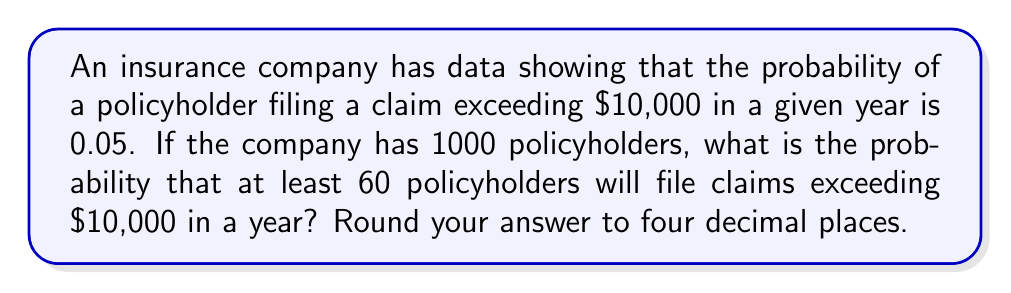Can you answer this question? To solve this problem, we'll use the binomial distribution and its normal approximation:

1) Let X be the number of policyholders filing claims exceeding $10,000.
   X follows a binomial distribution with n = 1000 and p = 0.05.

2) We need to find P(X ≥ 60).

3) For large n and np > 5, we can use the normal approximation to the binomial distribution.
   Here, n = 1000 and np = 1000 * 0.05 = 50 > 5, so we can use this approximation.

4) The mean of this distribution is:
   $$\mu = np = 1000 * 0.05 = 50$$

5) The standard deviation is:
   $$\sigma = \sqrt{np(1-p)} = \sqrt{1000 * 0.05 * 0.95} = \sqrt{47.5} \approx 6.892$$

6) We need to find P(X ≥ 60). Using the continuity correction:
   $$P(X \geq 60) = P(X > 59.5)$$

7) Convert to a z-score:
   $$z = \frac{59.5 - 50}{6.892} \approx 1.378$$

8) Using a standard normal table or calculator:
   $$P(Z > 1.378) = 1 - P(Z < 1.378) = 1 - 0.9159 = 0.0841$$

9) Rounding to four decimal places: 0.0841
Answer: 0.0841 